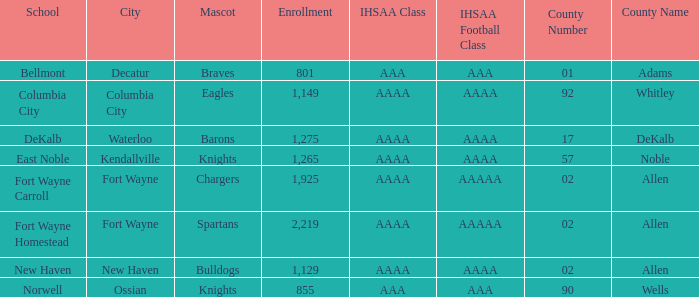What's the IHSAA Football Class in Decatur with an AAA IHSAA class? AAA. 